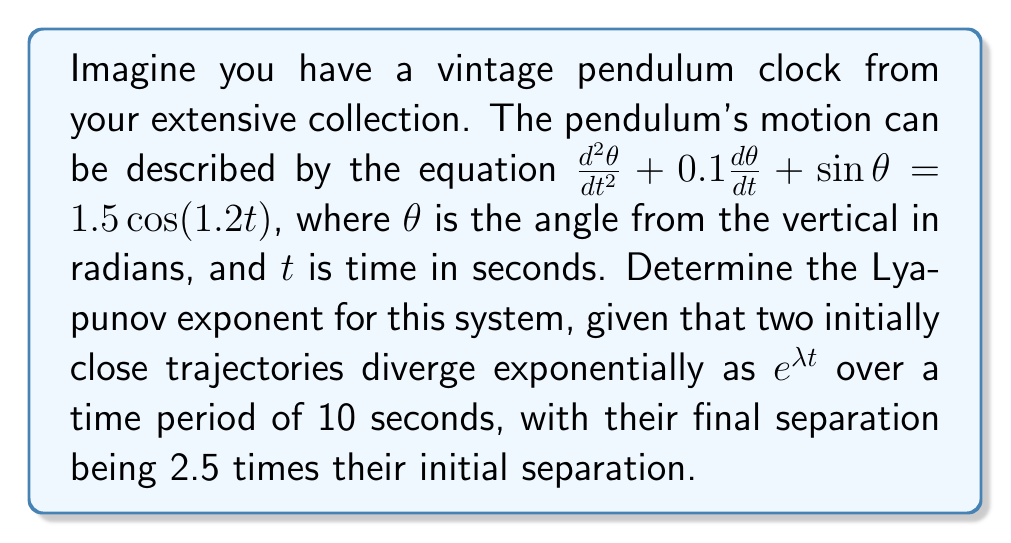Can you answer this question? To determine the Lyapunov exponent $\lambda$ for this pendulum clock system, we'll follow these steps:

1) The Lyapunov exponent $\lambda$ is defined by the equation:

   $$\lambda = \frac{1}{t}\ln\left(\frac{d(t)}{d(0)}\right)$$

   where $d(t)$ is the separation of two initially close trajectories at time $t$, and $d(0)$ is their initial separation.

2) We're given that the final separation is 2.5 times the initial separation after 10 seconds. So:

   $$\frac{d(10)}{d(0)} = 2.5$$

3) Substituting these values into the Lyapunov exponent equation:

   $$\lambda = \frac{1}{10}\ln\left(\frac{d(10)}{d(0)}\right) = \frac{1}{10}\ln(2.5)$$

4) Calculate the natural logarithm of 2.5:

   $$\ln(2.5) \approx 0.9163$$

5) Divide by 10 to get the final result:

   $$\lambda = \frac{0.9163}{10} \approx 0.09163$$

This positive Lyapunov exponent indicates that the system is chaotic, as nearby trajectories diverge exponentially over time.
Answer: $\lambda \approx 0.09163$ 